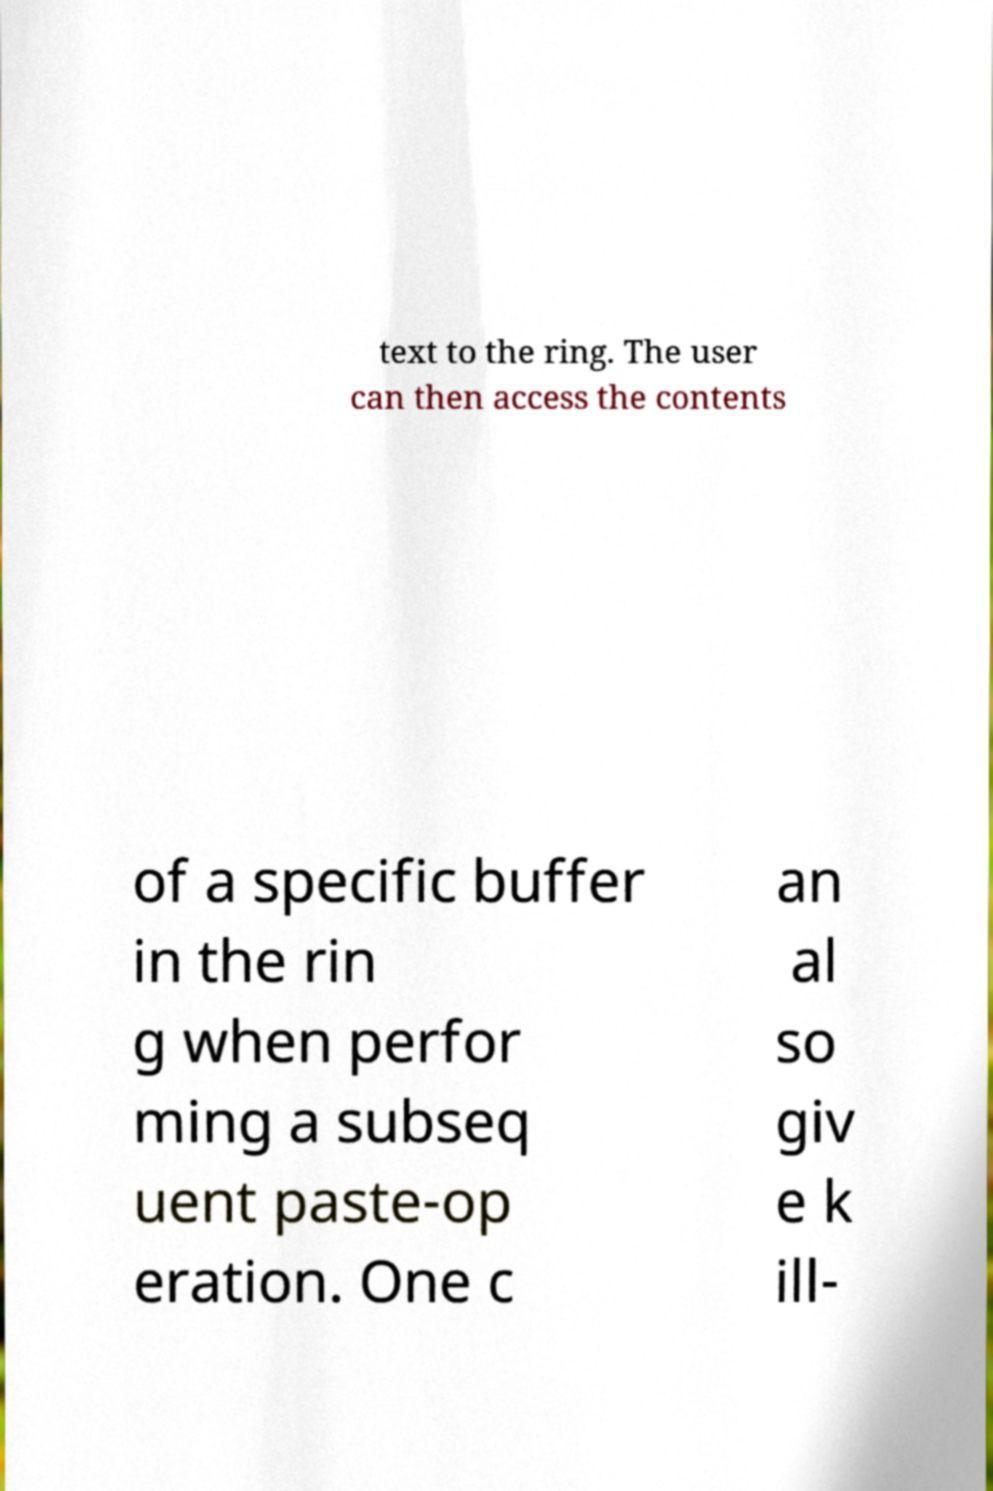I need the written content from this picture converted into text. Can you do that? text to the ring. The user can then access the contents of a specific buffer in the rin g when perfor ming a subseq uent paste-op eration. One c an al so giv e k ill- 